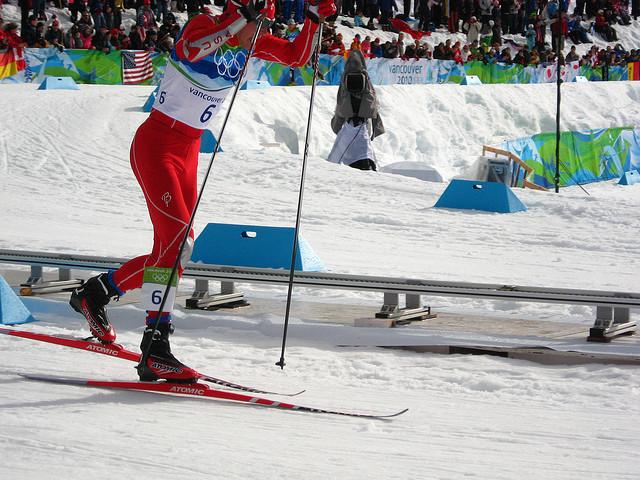What color flag is this?
Answer briefly. Red. What color are the skis?
Quick response, please. Red. What number contestant is he?
Concise answer only. 6. What color are the Olympic rings?
Be succinct. White. What famous games is the skier a contestant in?
Keep it brief. Olympics. 